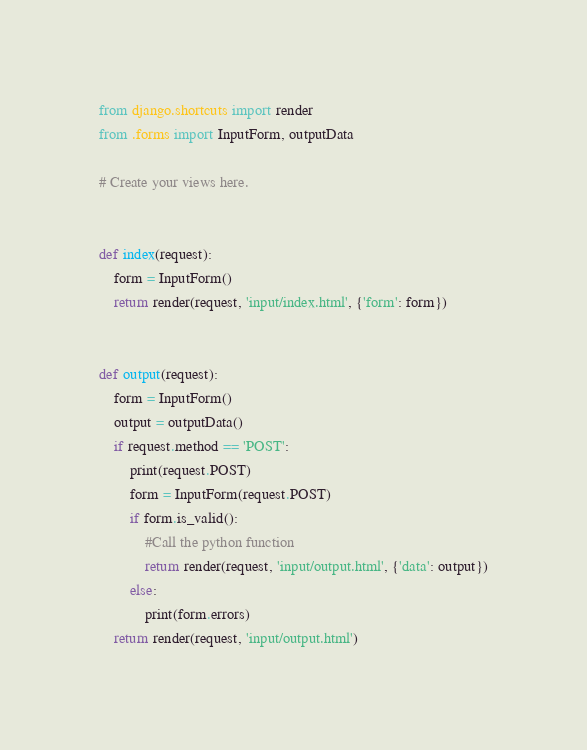Convert code to text. <code><loc_0><loc_0><loc_500><loc_500><_Python_>from django.shortcuts import render
from .forms import InputForm, outputData

# Create your views here.


def index(request):
	form = InputForm()
	return render(request, 'input/index.html', {'form': form})


def output(request):
	form = InputForm()
	output = outputData()
	if request.method == 'POST':
		print(request.POST)
		form = InputForm(request.POST)
		if form.is_valid():
			#Call the python function
			return render(request, 'input/output.html', {'data': output})
		else:
			print(form.errors)
	return render(request, 'input/output.html')
</code> 